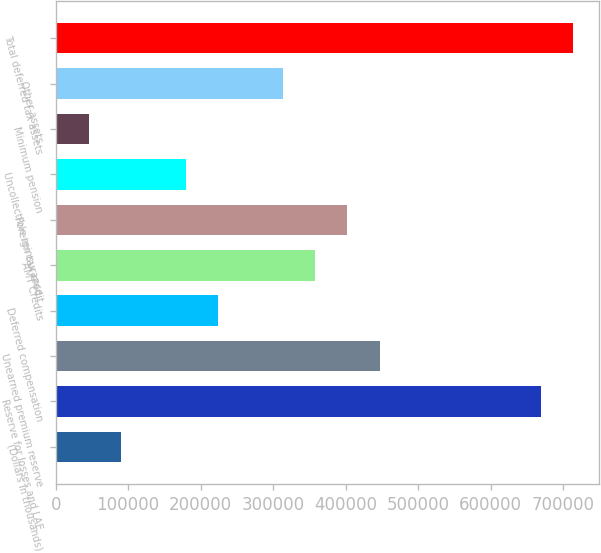<chart> <loc_0><loc_0><loc_500><loc_500><bar_chart><fcel>(Dollars in thousands)<fcel>Reserve for losses and LAE<fcel>Unearned premium reserve<fcel>Deferred compensation<fcel>AMT Credits<fcel>Foreign tax credit<fcel>Uncollectible reinsurance<fcel>Minimum pension<fcel>Other assets<fcel>Total deferred tax assets<nl><fcel>90461.4<fcel>669790<fcel>446971<fcel>224152<fcel>357844<fcel>402407<fcel>179589<fcel>45897.7<fcel>313280<fcel>714353<nl></chart> 